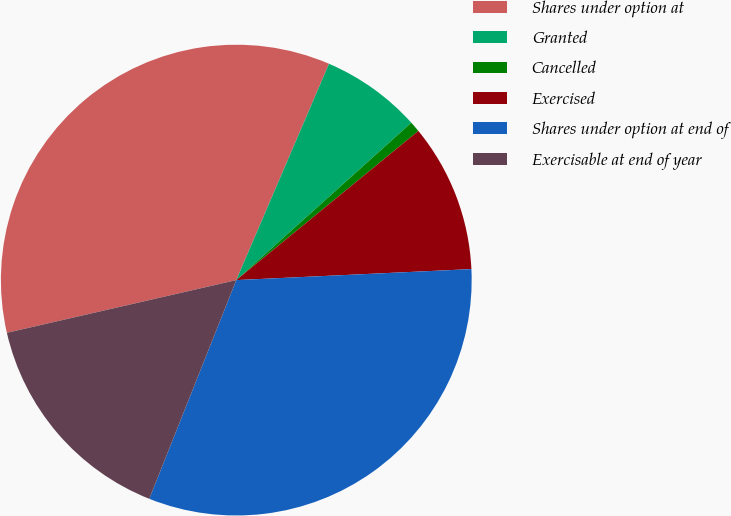Convert chart to OTSL. <chart><loc_0><loc_0><loc_500><loc_500><pie_chart><fcel>Shares under option at<fcel>Granted<fcel>Cancelled<fcel>Exercised<fcel>Shares under option at end of<fcel>Exercisable at end of year<nl><fcel>35.04%<fcel>6.9%<fcel>0.73%<fcel>10.18%<fcel>31.77%<fcel>15.38%<nl></chart> 